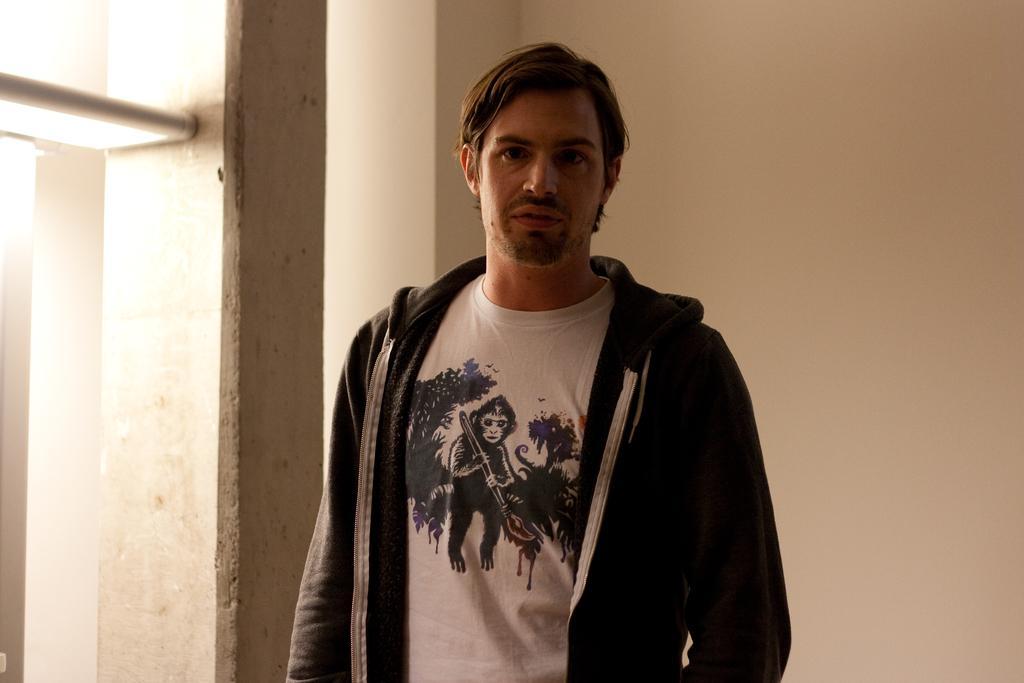In one or two sentences, can you explain what this image depicts? In this image we can see a man is standing. He is wearing a white t-shirt with a black hoodie. Behind the man, we can see a white wall, pillar and light. 